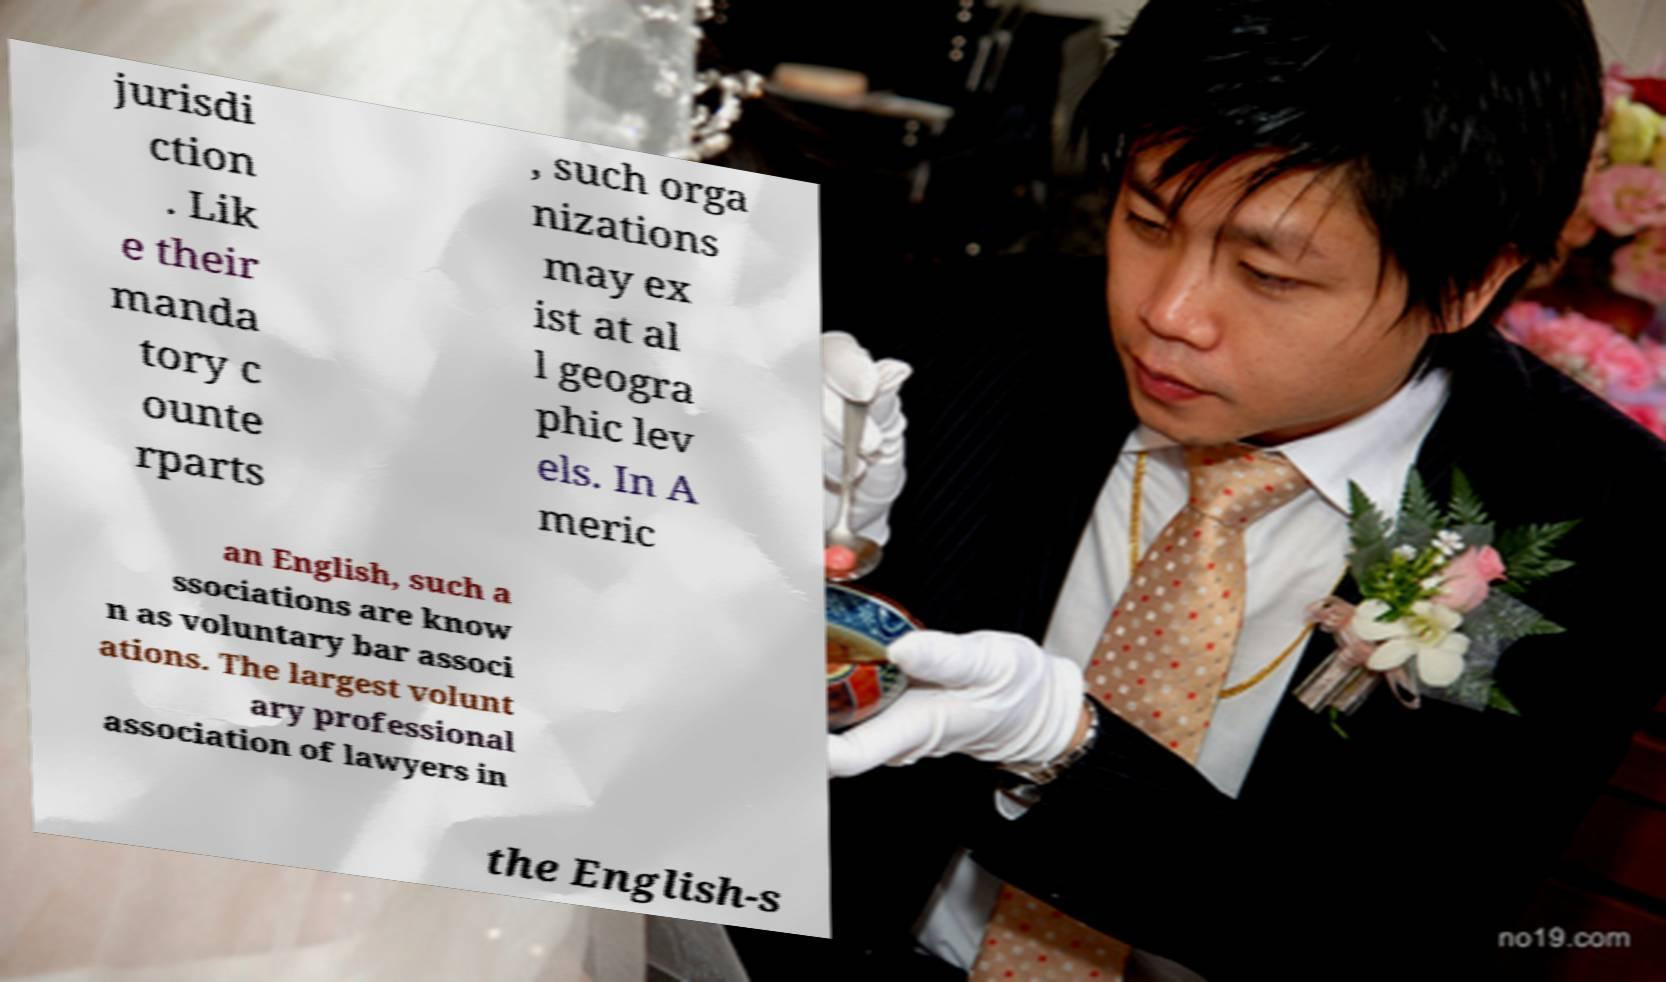Please identify and transcribe the text found in this image. jurisdi ction . Lik e their manda tory c ounte rparts , such orga nizations may ex ist at al l geogra phic lev els. In A meric an English, such a ssociations are know n as voluntary bar associ ations. The largest volunt ary professional association of lawyers in the English-s 